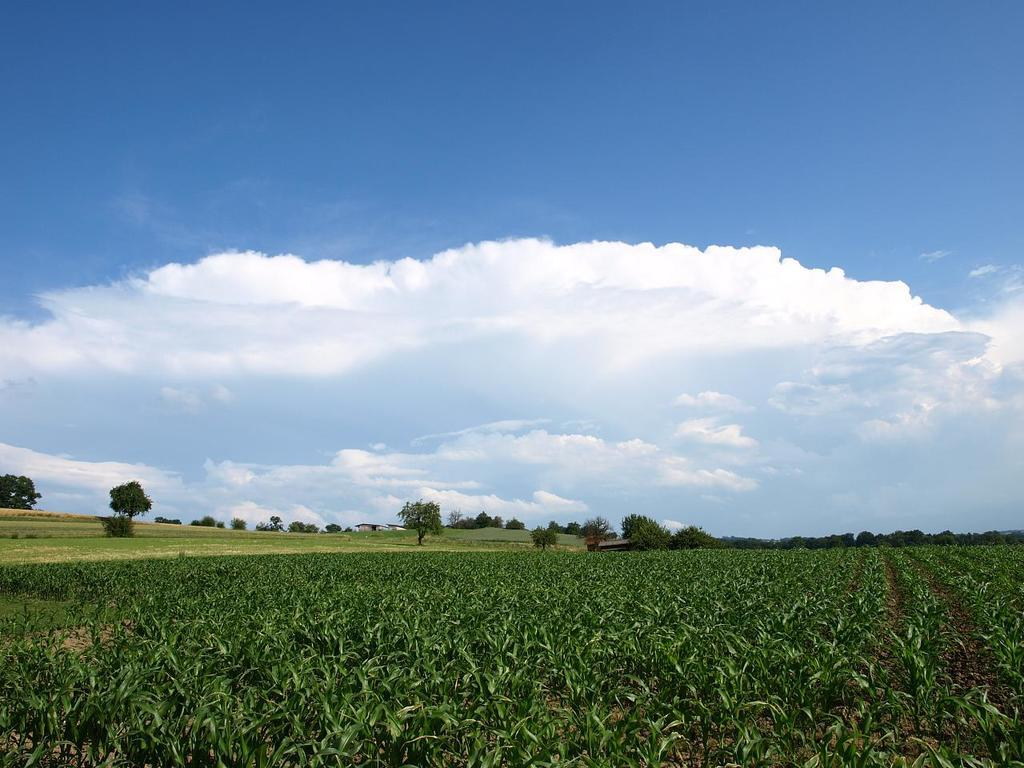What type of vegetation can be seen in the image? There are plants, green grass, and trees in the image. What is visible in the background of the image? The sky is visible in the background of the image. What colors can be seen in the sky? The sky has a combination of white and blue colors. How much juice is being consumed by the ghost in the image? There is no ghost or juice present in the image. 